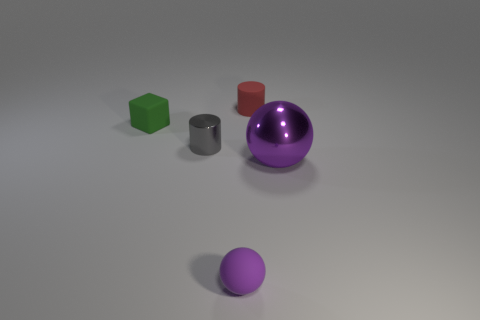How many things are things in front of the tiny green cube or tiny spheres?
Offer a terse response. 3. What number of other things are there of the same size as the metallic ball?
Your answer should be very brief. 0. How big is the purple sphere that is to the left of the small red thing?
Provide a short and direct response. Small. The green object that is the same material as the red object is what shape?
Provide a short and direct response. Cube. Are there any other things that are the same color as the small matte block?
Ensure brevity in your answer.  No. There is a shiny thing to the left of the purple sphere behind the small matte ball; what color is it?
Provide a short and direct response. Gray. How many tiny things are cylinders or gray shiny cylinders?
Offer a terse response. 2. What material is the other purple thing that is the same shape as the small purple thing?
Your response must be concise. Metal. The shiny cylinder is what color?
Make the answer very short. Gray. Does the large ball have the same color as the matte sphere?
Offer a terse response. Yes. 